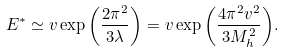<formula> <loc_0><loc_0><loc_500><loc_500>E ^ { * } \simeq v \exp { \left ( \frac { 2 \pi ^ { 2 } } { 3 \lambda } \right ) } = v \exp { \left ( \frac { 4 \pi ^ { 2 } v ^ { 2 } } { 3 M ^ { 2 } _ { h } } \right ) } .</formula> 